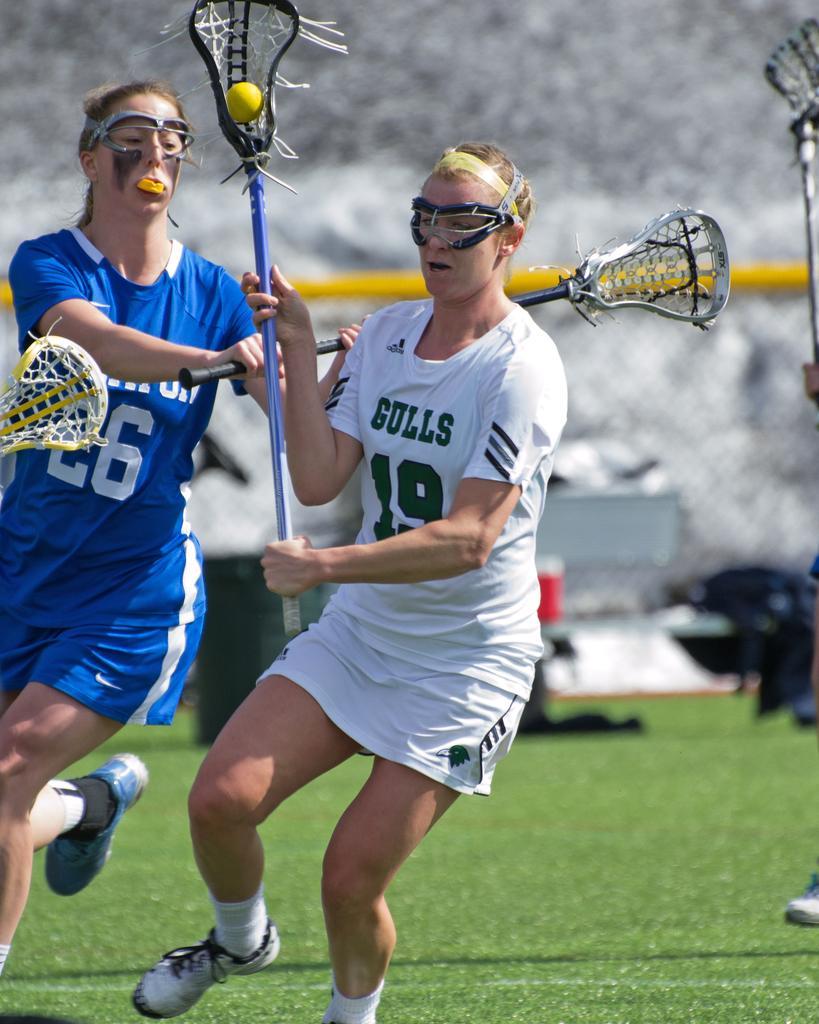How would you summarize this image in a sentence or two? This picture is clicked outside. In the center we can see the group of persons and we can see the persons wearing t-shirts, holding some objects and seems to be running and we can see a ball, metal rods, net, green grass and in the background we can see some other objects. 